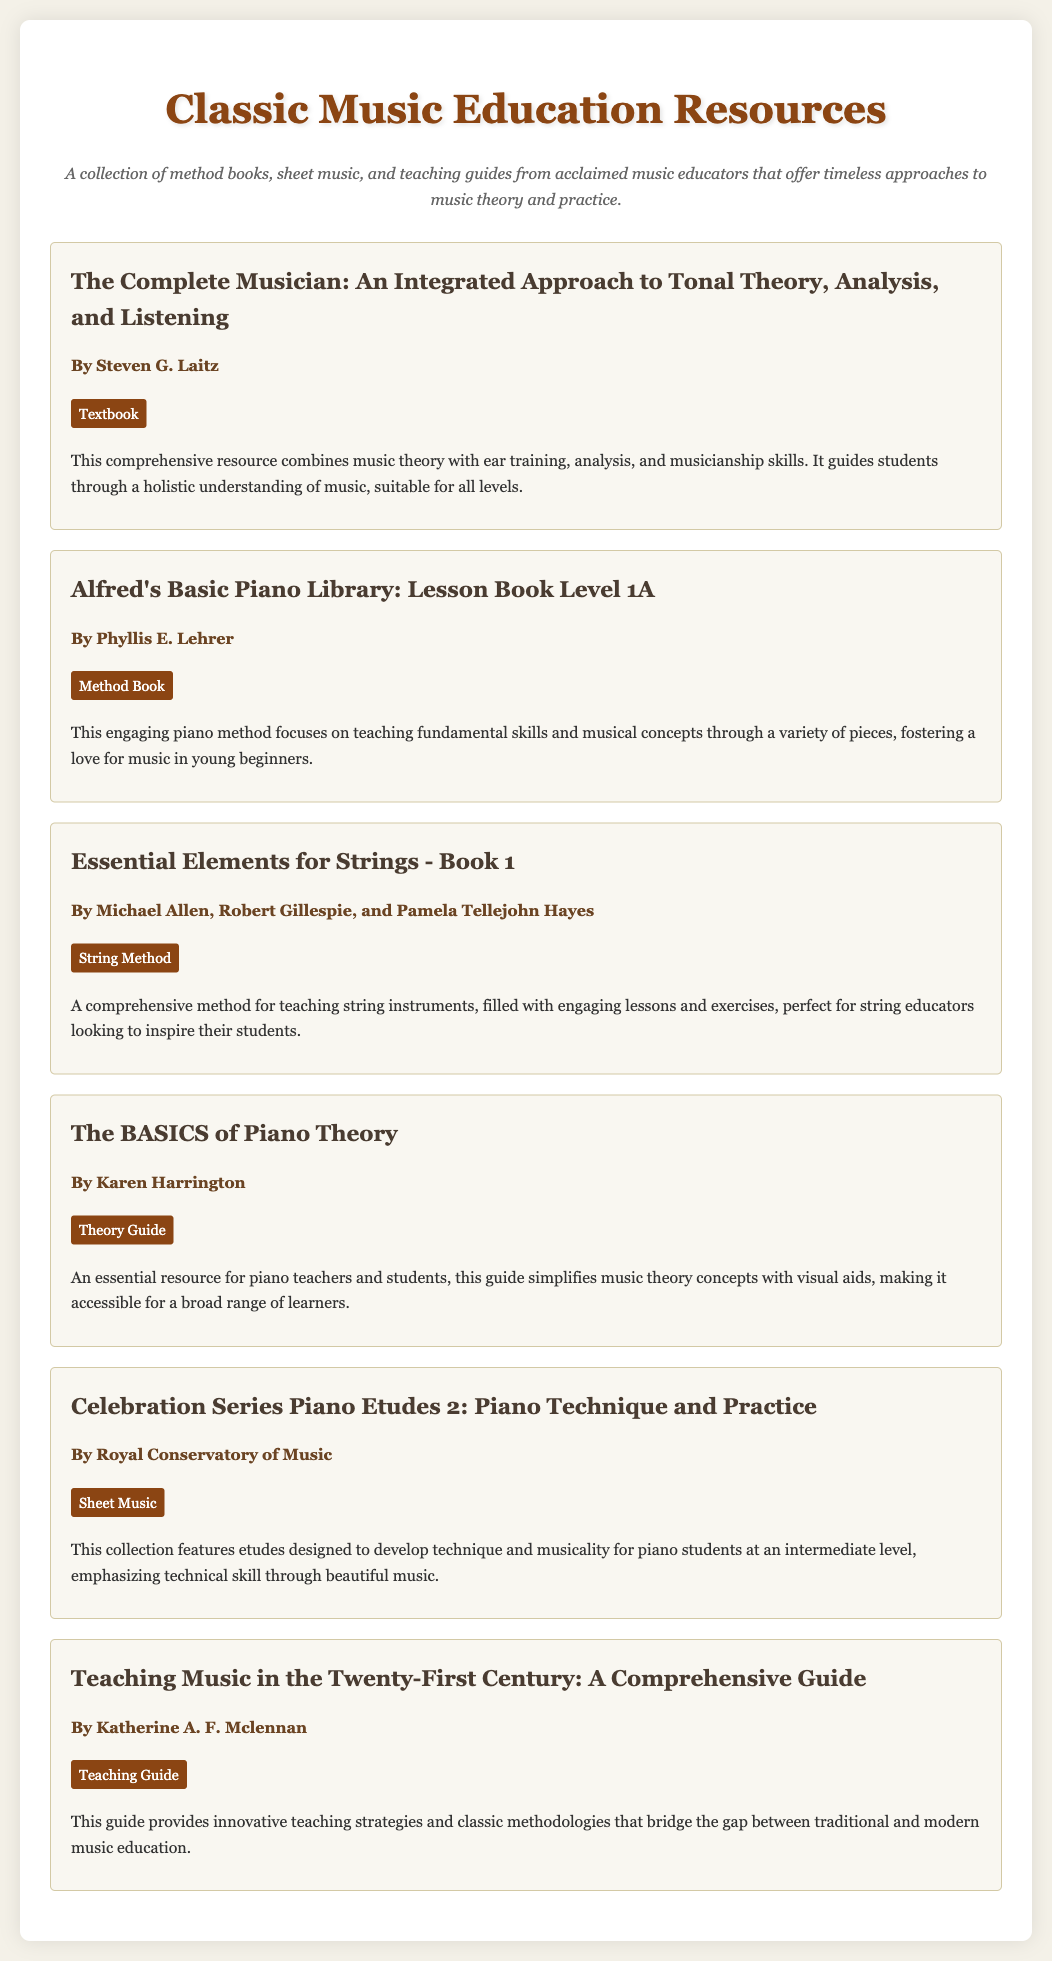What is the title of the first resource? The title of the first resource is found at the top of its section in the document.
Answer: The Complete Musician: An Integrated Approach to Tonal Theory, Analysis, and Listening Who is the author of "Essential Elements for Strings - Book 1"? The author's name is specified directly under the title of the resource in the document.
Answer: Michael Allen, Robert Gillespie, and Pamela Tellejohn Hayes What type of resource is "Teaching Music in the Twenty-First Century: A Comprehensive Guide"? The type of resource is indicated in a specific format within each resource's section in the document.
Answer: Teaching Guide How many intermediate-level pieces are in "Celebration Series Piano Etudes 2"? The document describes the collection, but does not specify the exact number of pieces within it.
Answer: Not specified What is the main focus of "Alfred's Basic Piano Library: Lesson Book Level 1A"? The focus of the resource is described in the summary section of the document.
Answer: Teaching fundamental skills and musical concepts Which resource is authored by Karen Harrington? The author’s name of this specific resource is listed directly under its title in the document.
Answer: The BASICS of Piano Theory What does "The Complete Musician" aim to provide students with? The aims of this resource are outlined in the description section which summarizes its contents.
Answer: A holistic understanding of music How does "The BASICS of Piano Theory" simplify music theory? The document provides a brief description indicating how it achieves this goal.
Answer: With visual aids 